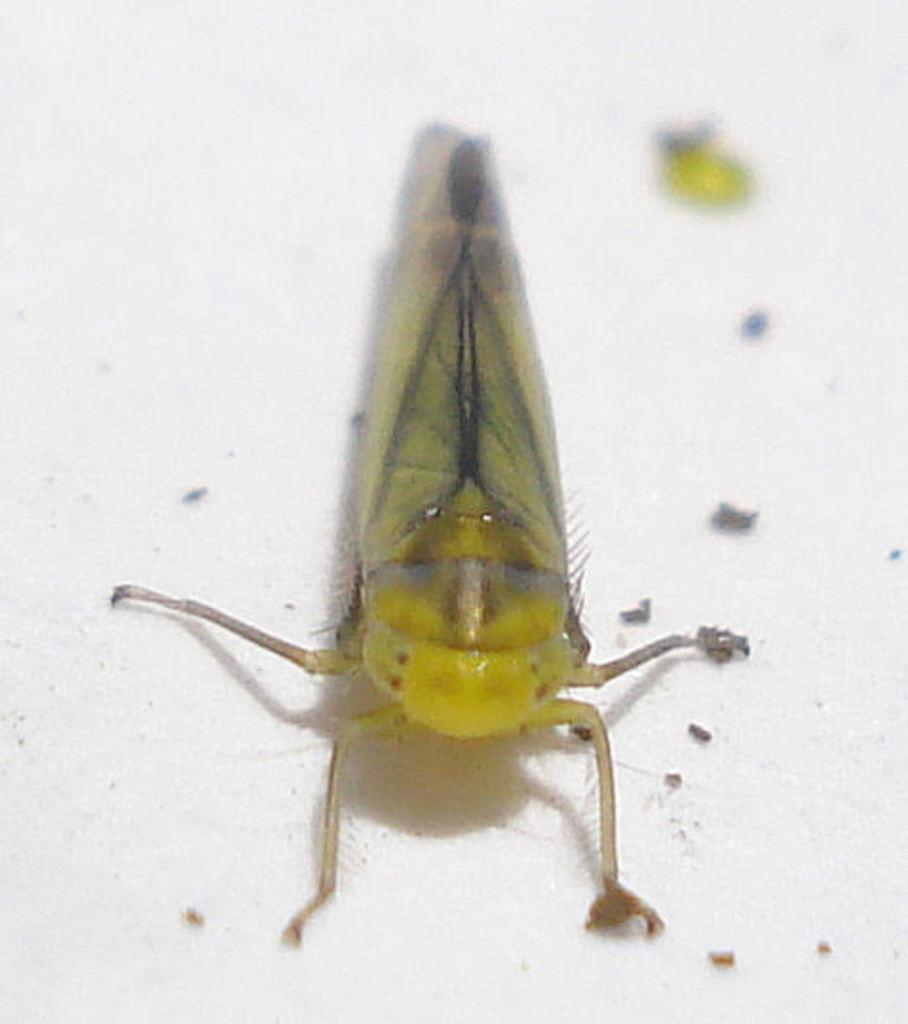What type of creature is present in the image? There is an insect in the image. Where is the insect located in the image? The insect is on the surface. What type of reaction does the insect have to the presence of a toe in the image? There is no toe present in the image, so it is not possible to determine the insect's reaction to it. 